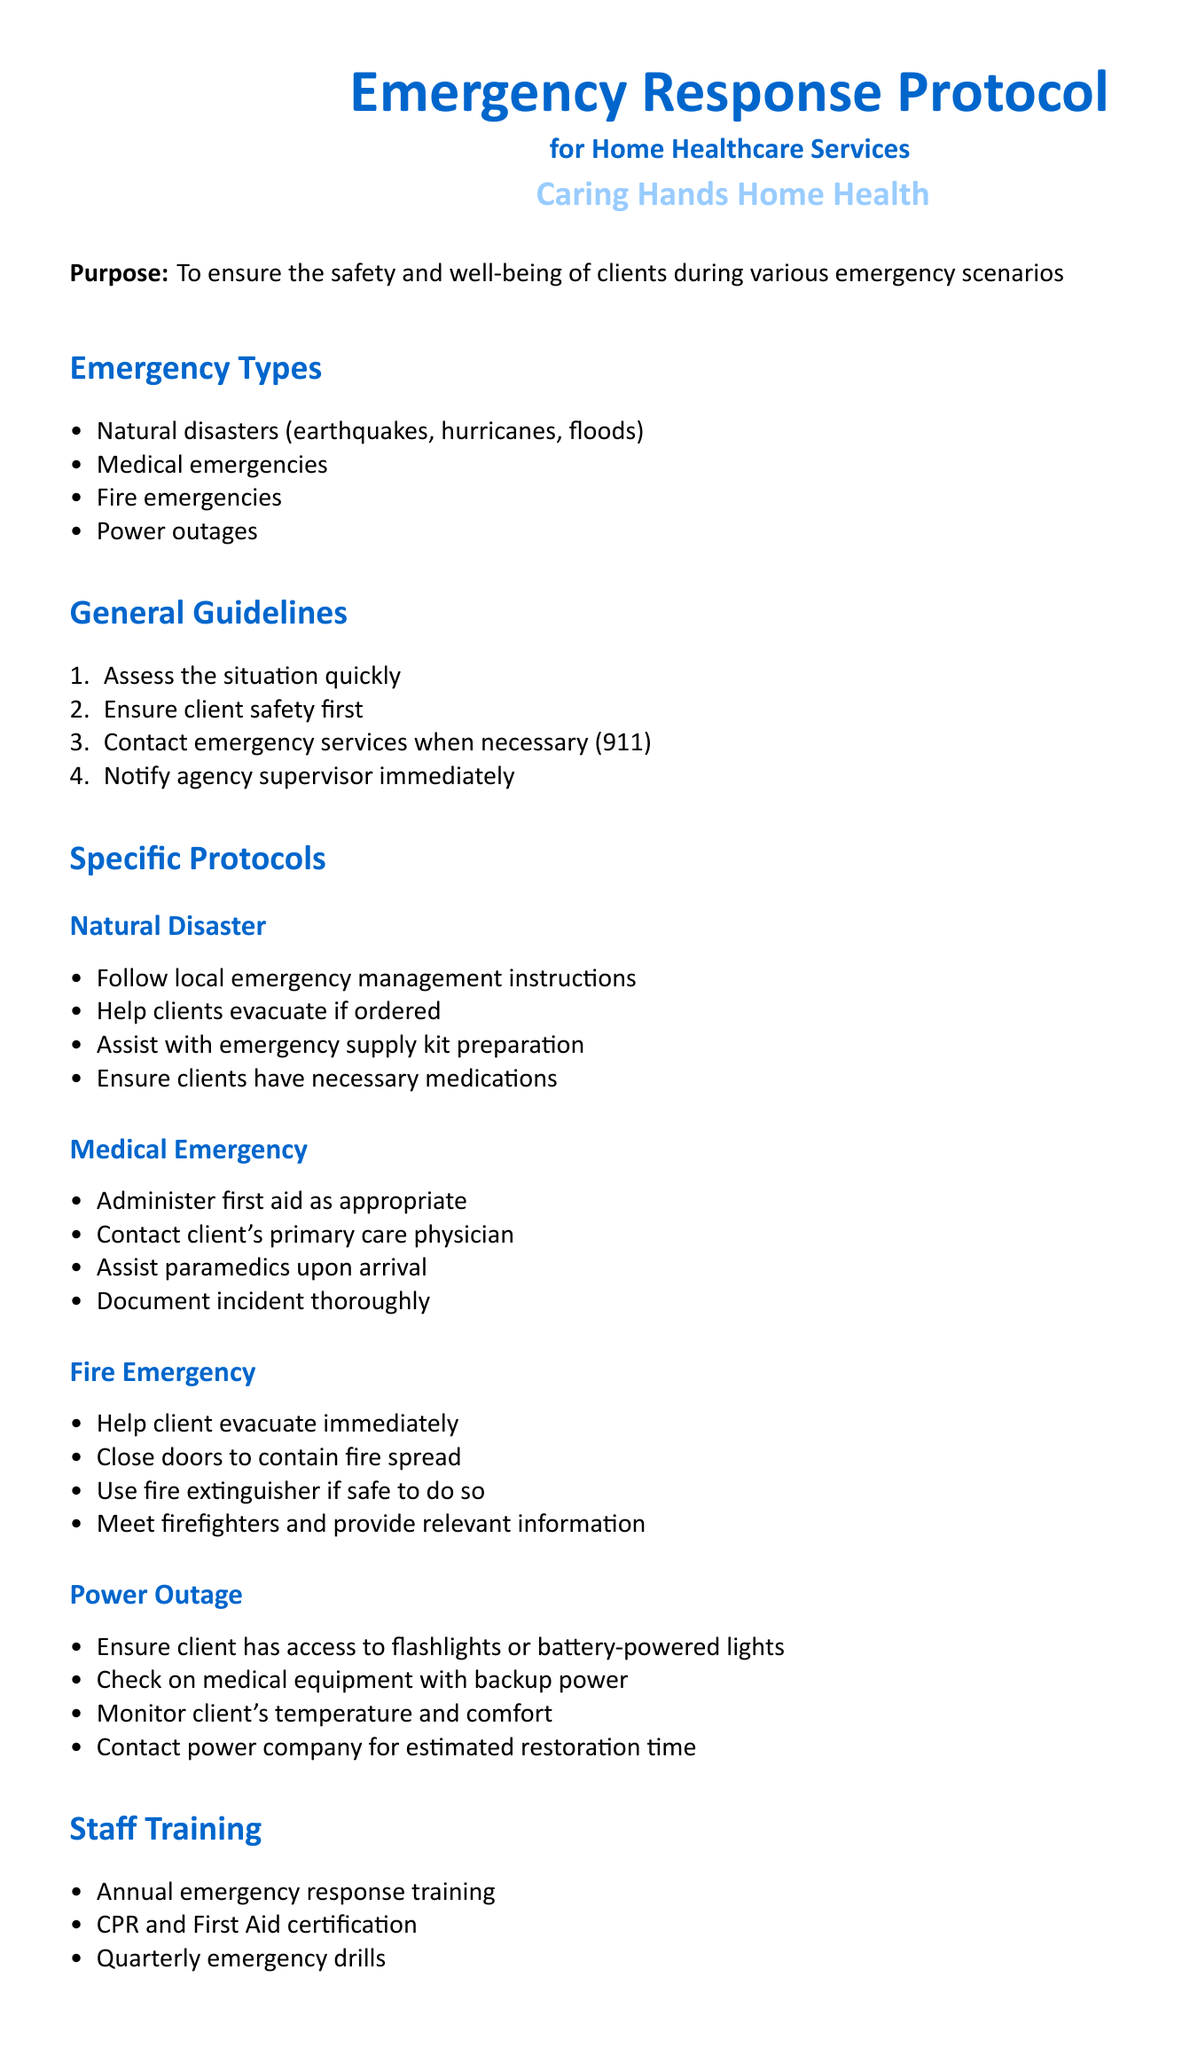What types of emergencies are covered in this protocol? The document lists the types of emergencies that the protocol covers, which include natural disasters, medical emergencies, fire emergencies, and power outages.
Answer: Natural disasters, medical emergencies, fire emergencies, power outages What is the first step in the General Guidelines? The first step listed in the General Guidelines is to assess the situation quickly.
Answer: Assess the situation quickly What should be done during a natural disaster? One of the specific protocols for natural disasters states to follow local emergency management instructions among others.
Answer: Follow local emergency management instructions What training is included in the Staff Training section? The document lists several training components, including annual emergency response training.
Answer: Annual emergency response training How often should the policy be reviewed? The document states that the policy shall be reviewed and updated annually or as needed.
Answer: Annually What is the purpose of this protocol? The document clearly outlines that its purpose is to ensure the safety and well-being of clients during various emergency scenarios.
Answer: Ensure the safety and well-being of clients What type of emergency requires contacting the client's primary care physician? The protocol for medical emergencies specifies that the primary care physician should be contacted.
Answer: Medical emergency How can staff assist during a fire emergency? One of the actions listed for staff during a fire emergency is to help evacuate the client immediately.
Answer: Help client evacuate immediately Which training certification is mentioned in the document? The document specifies CPR and First Aid certification as part of the training.
Answer: CPR and First Aid certification 